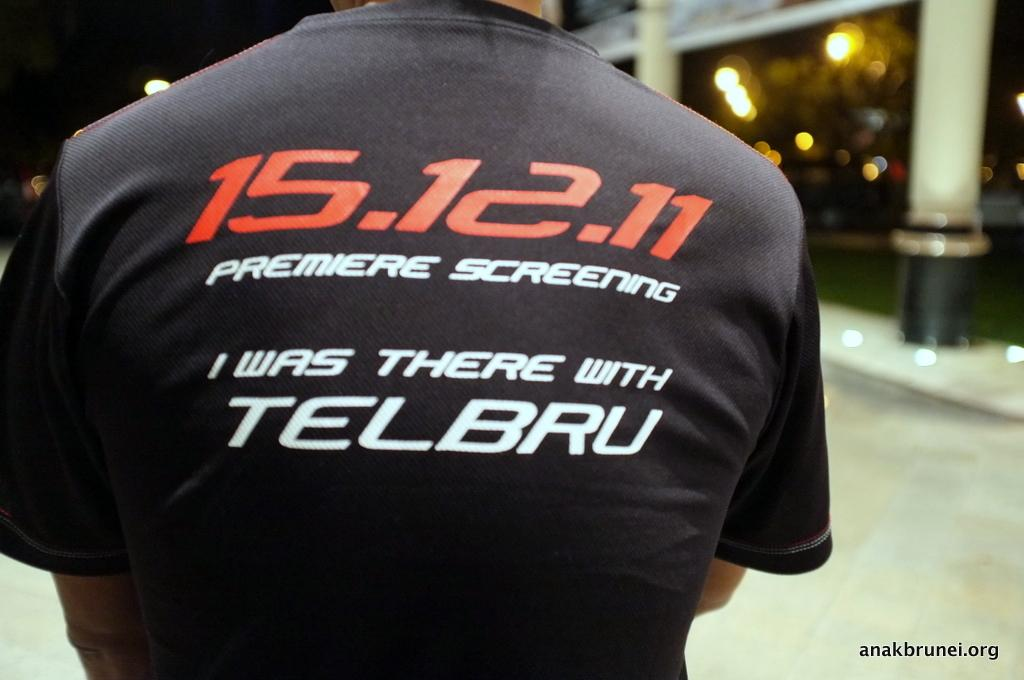Provide a one-sentence caption for the provided image. A closeup of the back of a man's shirt which shows 15.12.11 Premiere Screening I was there with Telbru. 